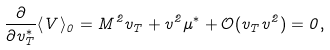<formula> <loc_0><loc_0><loc_500><loc_500>\frac { \partial } { \partial v _ { T } ^ { * } } \langle V \rangle _ { 0 } = M ^ { 2 } v _ { T } + v ^ { 2 } \mu ^ { * } + \mathcal { O } ( v _ { T } v ^ { 2 } ) = 0 ,</formula> 